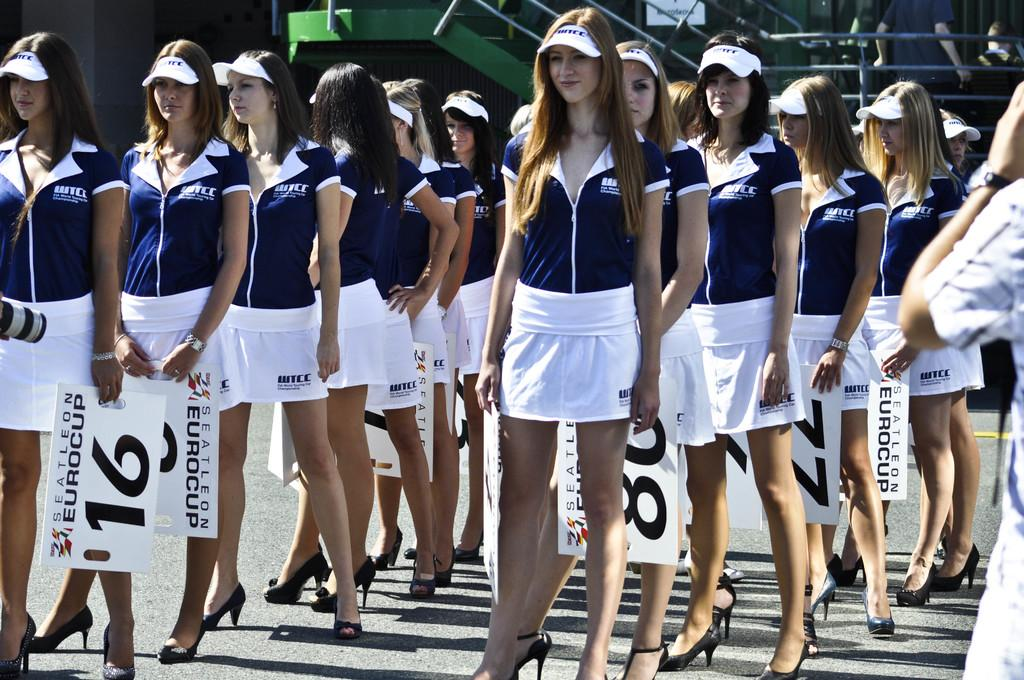<image>
Give a short and clear explanation of the subsequent image. A bunch of women gather holding signs that read EUROCUP. 